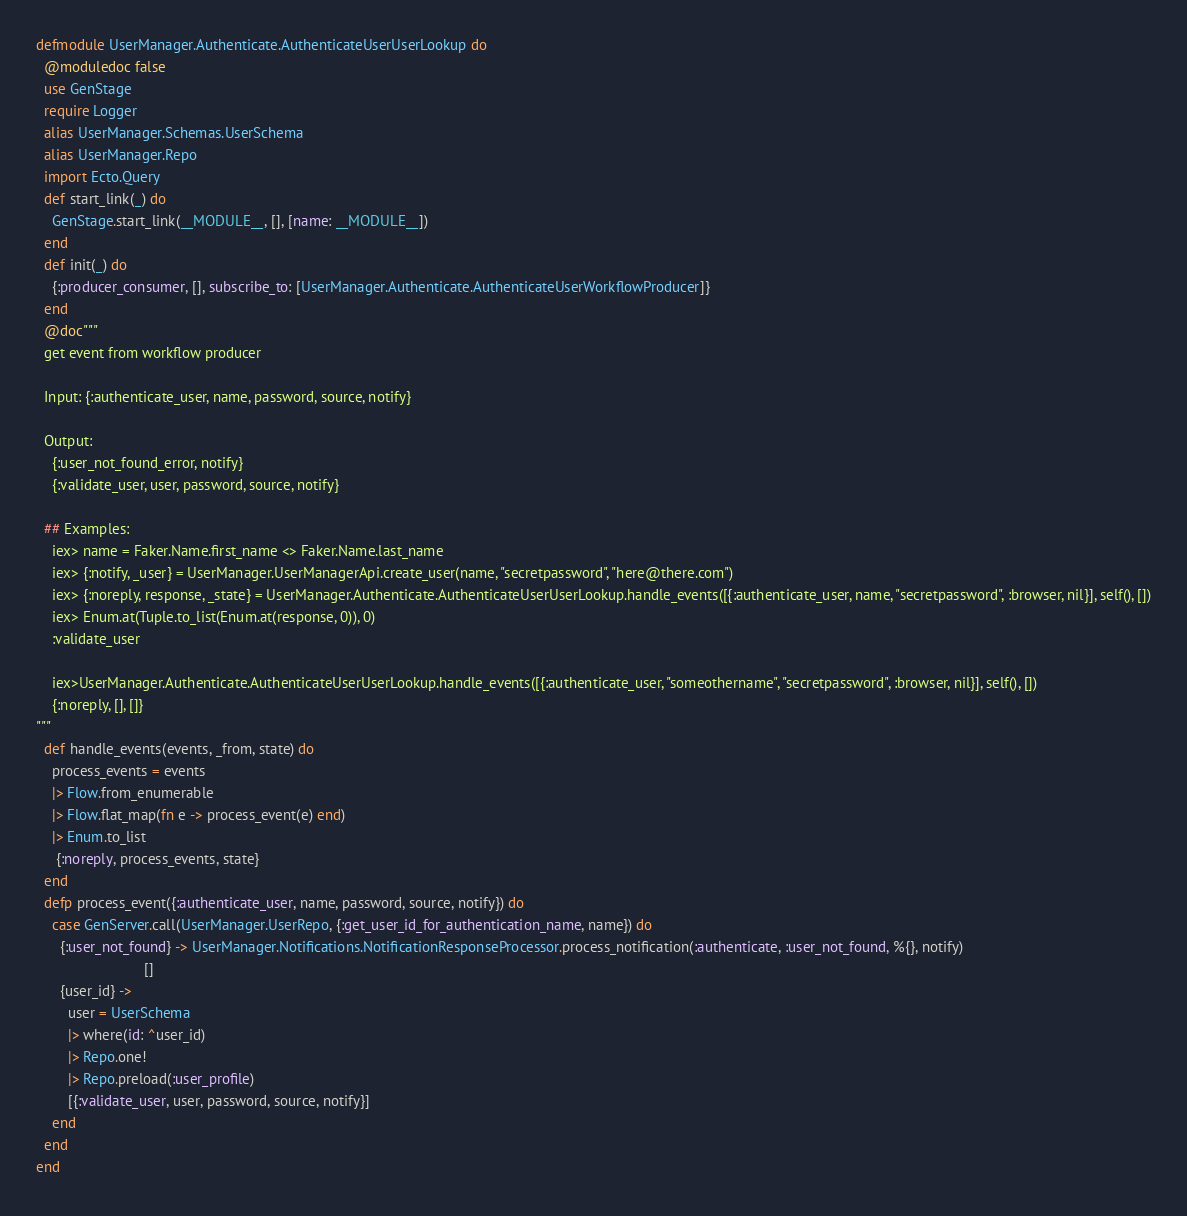Convert code to text. <code><loc_0><loc_0><loc_500><loc_500><_Elixir_>defmodule UserManager.Authenticate.AuthenticateUserUserLookup do
  @moduledoc false
  use GenStage
  require Logger
  alias UserManager.Schemas.UserSchema
  alias UserManager.Repo
  import Ecto.Query
  def start_link(_) do
    GenStage.start_link(__MODULE__, [], [name: __MODULE__])
  end
  def init(_) do
    {:producer_consumer, [], subscribe_to: [UserManager.Authenticate.AuthenticateUserWorkflowProducer]}
  end
  @doc"""
  get event from workflow producer

  Input: {:authenticate_user, name, password, source, notify}

  Output:
    {:user_not_found_error, notify}
    {:validate_user, user, password, source, notify}

  ## Examples:
    iex> name = Faker.Name.first_name <> Faker.Name.last_name
    iex> {:notify, _user} = UserManager.UserManagerApi.create_user(name, "secretpassword", "here@there.com")
    iex> {:noreply, response, _state} = UserManager.Authenticate.AuthenticateUserUserLookup.handle_events([{:authenticate_user, name, "secretpassword", :browser, nil}], self(), [])
    iex> Enum.at(Tuple.to_list(Enum.at(response, 0)), 0)
    :validate_user

    iex>UserManager.Authenticate.AuthenticateUserUserLookup.handle_events([{:authenticate_user, "someothername", "secretpassword", :browser, nil}], self(), [])
    {:noreply, [], []}
"""
  def handle_events(events, _from, state) do
    process_events = events
    |> Flow.from_enumerable
    |> Flow.flat_map(fn e -> process_event(e) end)
    |> Enum.to_list
     {:noreply, process_events, state}
  end
  defp process_event({:authenticate_user, name, password, source, notify}) do
    case GenServer.call(UserManager.UserRepo, {:get_user_id_for_authentication_name, name}) do
      {:user_not_found} -> UserManager.Notifications.NotificationResponseProcessor.process_notification(:authenticate, :user_not_found, %{}, notify)
                           []
      {user_id} ->
        user = UserSchema
        |> where(id: ^user_id)
        |> Repo.one!
        |> Repo.preload(:user_profile)
        [{:validate_user, user, password, source, notify}]
    end
  end
end
</code> 